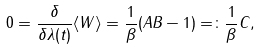<formula> <loc_0><loc_0><loc_500><loc_500>0 = \frac { \delta } { \delta \lambda ( t ) } \langle W \rangle = \frac { 1 } { \beta } ( A B - 1 ) = \colon \frac { 1 } { \beta } C ,</formula> 